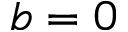Convert formula to latex. <formula><loc_0><loc_0><loc_500><loc_500>b = 0</formula> 